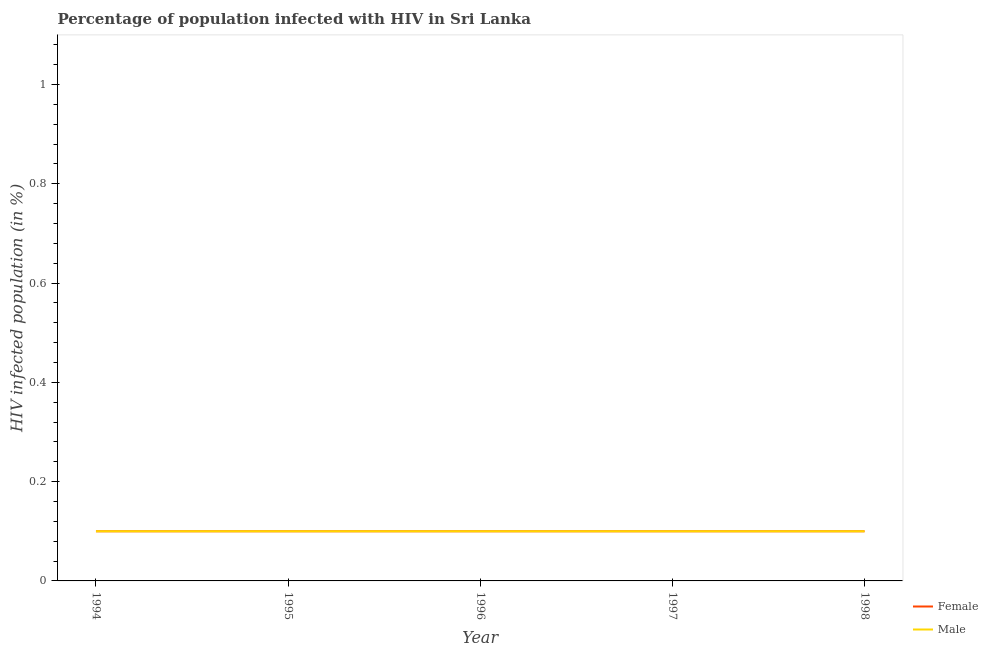Does the line corresponding to percentage of males who are infected with hiv intersect with the line corresponding to percentage of females who are infected with hiv?
Your answer should be compact. Yes. What is the total percentage of males who are infected with hiv in the graph?
Your response must be concise. 0.5. What is the difference between the percentage of males who are infected with hiv in 1994 and the percentage of females who are infected with hiv in 1996?
Your response must be concise. 0. What is the average percentage of males who are infected with hiv per year?
Provide a short and direct response. 0.1. What is the ratio of the percentage of males who are infected with hiv in 1995 to that in 1996?
Give a very brief answer. 1. Is the percentage of females who are infected with hiv in 1994 less than that in 1998?
Ensure brevity in your answer.  No. Is the sum of the percentage of females who are infected with hiv in 1994 and 1998 greater than the maximum percentage of males who are infected with hiv across all years?
Provide a short and direct response. Yes. Does the percentage of males who are infected with hiv monotonically increase over the years?
Your response must be concise. No. Is the percentage of females who are infected with hiv strictly greater than the percentage of males who are infected with hiv over the years?
Offer a very short reply. No. How many lines are there?
Your answer should be very brief. 2. How many years are there in the graph?
Give a very brief answer. 5. What is the difference between two consecutive major ticks on the Y-axis?
Your response must be concise. 0.2. Does the graph contain any zero values?
Keep it short and to the point. No. How many legend labels are there?
Offer a terse response. 2. How are the legend labels stacked?
Offer a very short reply. Vertical. What is the title of the graph?
Keep it short and to the point. Percentage of population infected with HIV in Sri Lanka. Does "Forest land" appear as one of the legend labels in the graph?
Ensure brevity in your answer.  No. What is the label or title of the Y-axis?
Offer a very short reply. HIV infected population (in %). What is the HIV infected population (in %) of Female in 1994?
Provide a succinct answer. 0.1. What is the HIV infected population (in %) in Male in 1994?
Give a very brief answer. 0.1. What is the HIV infected population (in %) in Male in 1995?
Offer a very short reply. 0.1. What is the HIV infected population (in %) in Male in 1996?
Make the answer very short. 0.1. What is the HIV infected population (in %) of Male in 1997?
Provide a short and direct response. 0.1. What is the HIV infected population (in %) of Female in 1998?
Provide a short and direct response. 0.1. Across all years, what is the maximum HIV infected population (in %) of Female?
Offer a very short reply. 0.1. Across all years, what is the maximum HIV infected population (in %) in Male?
Provide a succinct answer. 0.1. Across all years, what is the minimum HIV infected population (in %) in Female?
Keep it short and to the point. 0.1. What is the total HIV infected population (in %) of Female in the graph?
Your response must be concise. 0.5. What is the difference between the HIV infected population (in %) in Female in 1994 and that in 1997?
Offer a very short reply. 0. What is the difference between the HIV infected population (in %) of Male in 1994 and that in 1997?
Ensure brevity in your answer.  0. What is the difference between the HIV infected population (in %) in Female in 1995 and that in 1996?
Offer a terse response. 0. What is the difference between the HIV infected population (in %) in Male in 1995 and that in 1996?
Your answer should be compact. 0. What is the difference between the HIV infected population (in %) of Male in 1995 and that in 1997?
Make the answer very short. 0. What is the difference between the HIV infected population (in %) in Female in 1995 and that in 1998?
Give a very brief answer. 0. What is the difference between the HIV infected population (in %) of Female in 1996 and that in 1997?
Make the answer very short. 0. What is the difference between the HIV infected population (in %) in Male in 1996 and that in 1997?
Keep it short and to the point. 0. What is the difference between the HIV infected population (in %) in Female in 1996 and that in 1998?
Keep it short and to the point. 0. What is the difference between the HIV infected population (in %) of Female in 1994 and the HIV infected population (in %) of Male in 1996?
Your answer should be very brief. 0. What is the difference between the HIV infected population (in %) in Female in 1996 and the HIV infected population (in %) in Male in 1997?
Keep it short and to the point. 0. What is the difference between the HIV infected population (in %) of Female in 1996 and the HIV infected population (in %) of Male in 1998?
Keep it short and to the point. 0. What is the difference between the HIV infected population (in %) in Female in 1997 and the HIV infected population (in %) in Male in 1998?
Keep it short and to the point. 0. What is the average HIV infected population (in %) in Male per year?
Make the answer very short. 0.1. In the year 1996, what is the difference between the HIV infected population (in %) in Female and HIV infected population (in %) in Male?
Your answer should be compact. 0. What is the ratio of the HIV infected population (in %) in Male in 1994 to that in 1998?
Keep it short and to the point. 1. What is the ratio of the HIV infected population (in %) in Female in 1995 to that in 1996?
Give a very brief answer. 1. What is the ratio of the HIV infected population (in %) in Male in 1995 to that in 1996?
Your response must be concise. 1. What is the ratio of the HIV infected population (in %) in Female in 1995 to that in 1997?
Provide a short and direct response. 1. What is the ratio of the HIV infected population (in %) in Female in 1995 to that in 1998?
Offer a terse response. 1. What is the ratio of the HIV infected population (in %) of Female in 1996 to that in 1997?
Provide a short and direct response. 1. What is the ratio of the HIV infected population (in %) in Male in 1996 to that in 1997?
Your answer should be compact. 1. What is the ratio of the HIV infected population (in %) of Female in 1997 to that in 1998?
Ensure brevity in your answer.  1. 